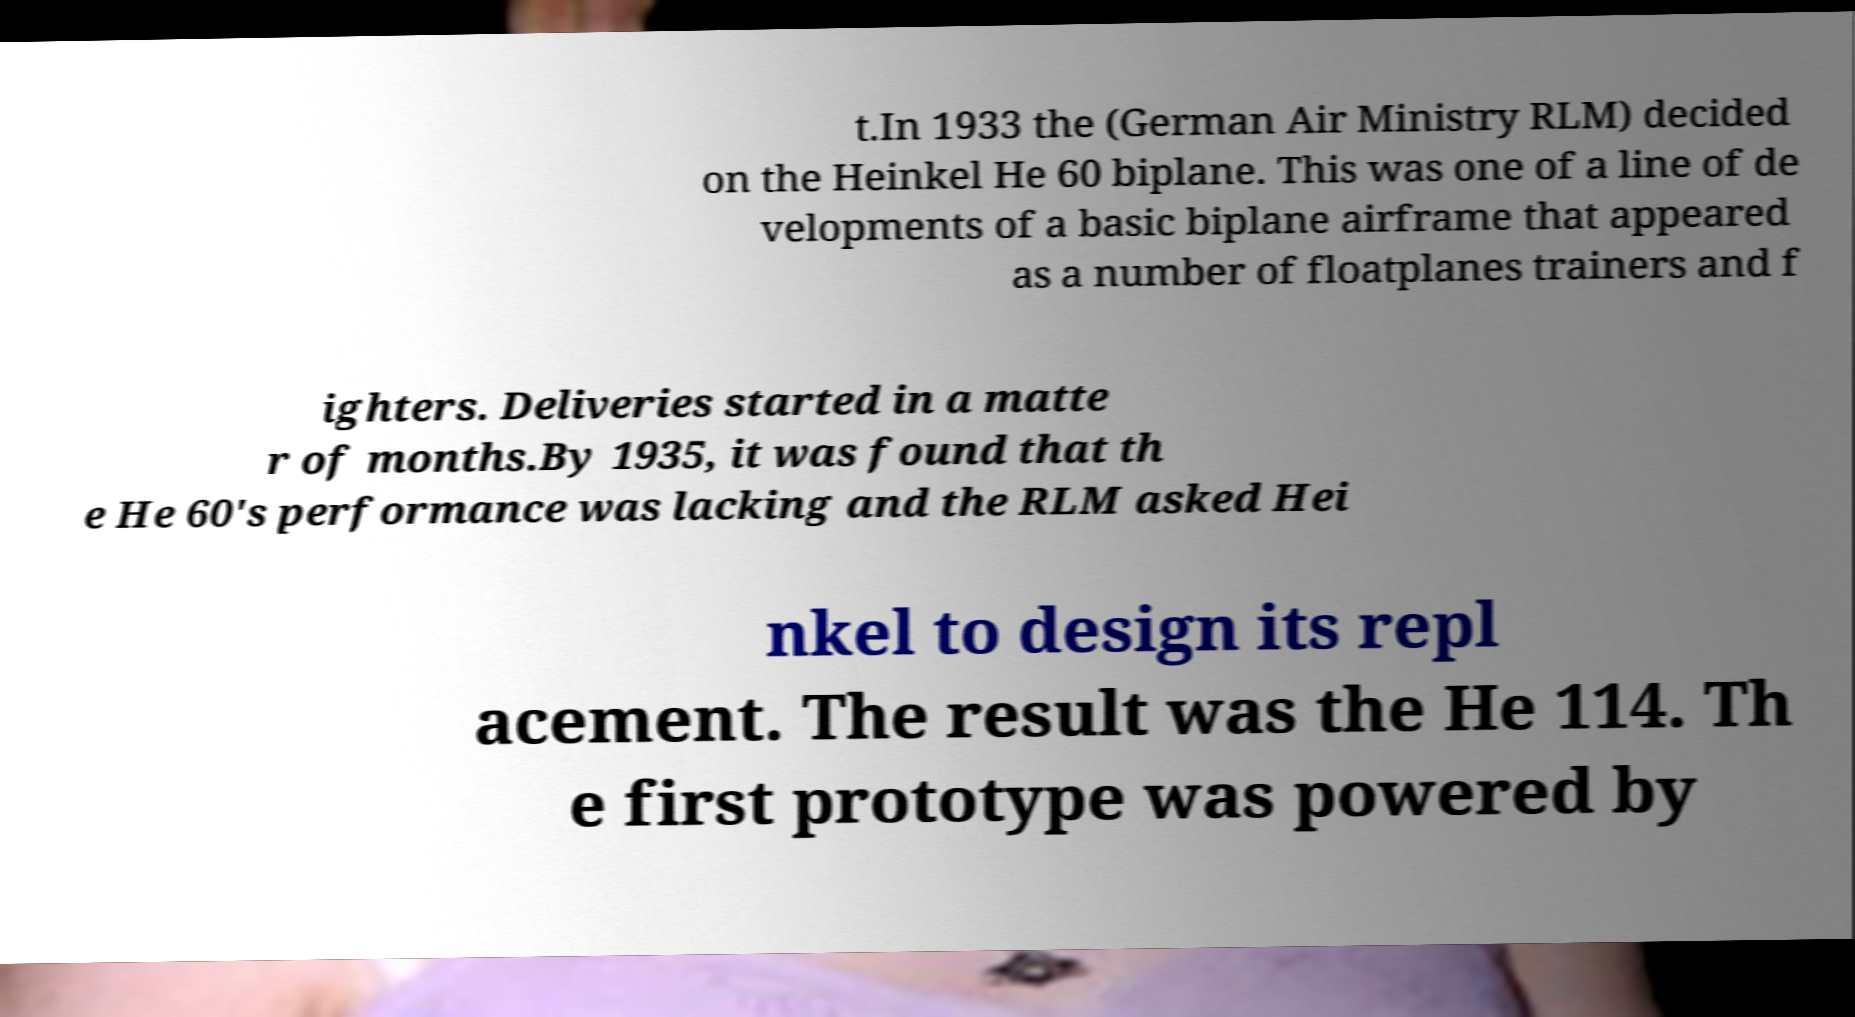What messages or text are displayed in this image? I need them in a readable, typed format. t.In 1933 the (German Air Ministry RLM) decided on the Heinkel He 60 biplane. This was one of a line of de velopments of a basic biplane airframe that appeared as a number of floatplanes trainers and f ighters. Deliveries started in a matte r of months.By 1935, it was found that th e He 60's performance was lacking and the RLM asked Hei nkel to design its repl acement. The result was the He 114. Th e first prototype was powered by 